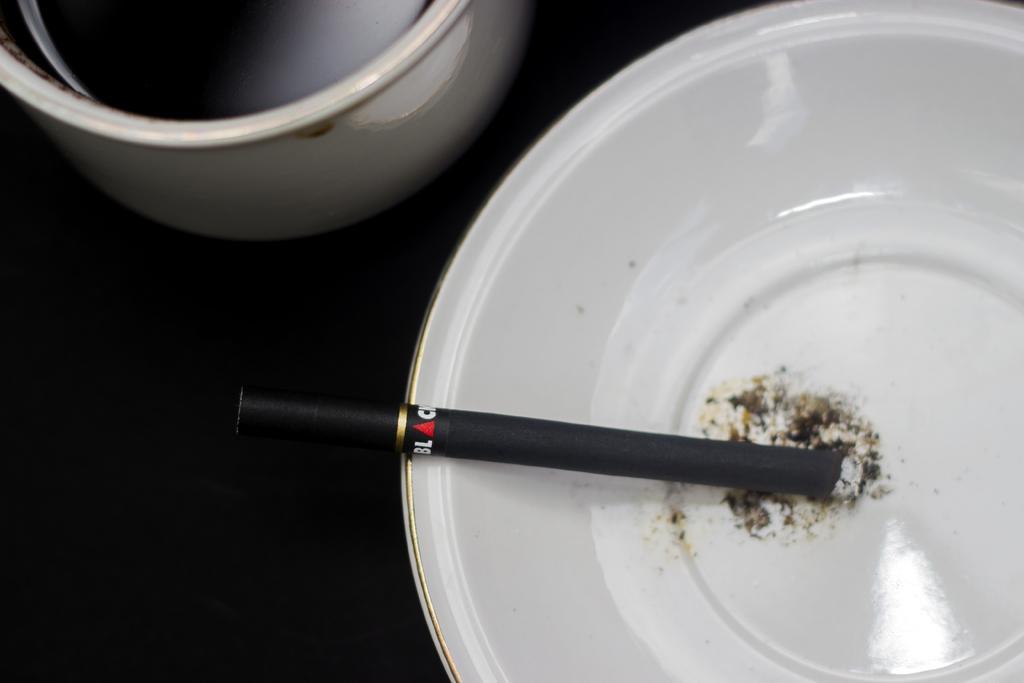Can you describe this image briefly? In this image we can see black color cigarette in a white color bowl. Left top of the image one container is there on the black surface. 